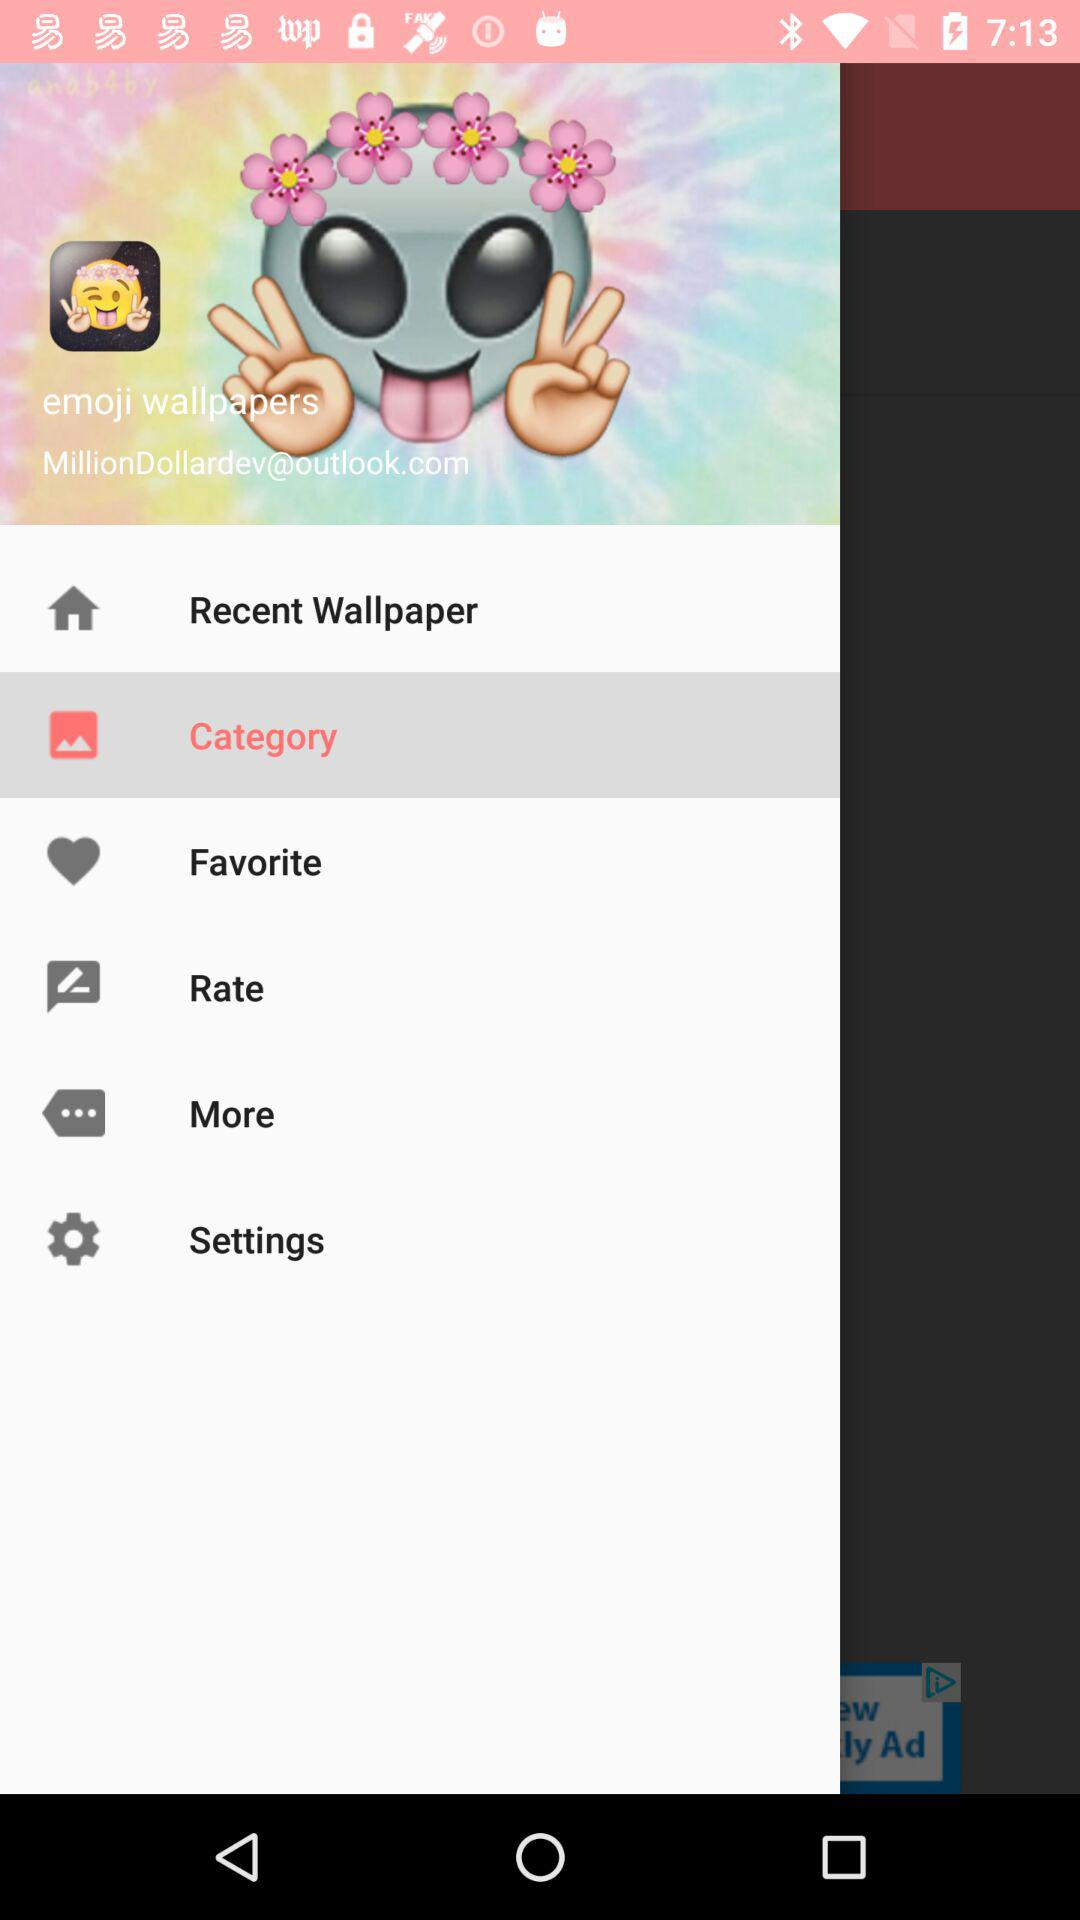Which item has been selected? The selected item is "Category". 